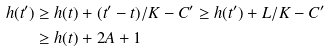<formula> <loc_0><loc_0><loc_500><loc_500>h ( t ^ { \prime } ) & \geq h ( t ) + ( t ^ { \prime } - t ) / K - C ^ { \prime } \geq h ( t ^ { \prime } ) + L / K - C ^ { \prime } \\ & \geq h ( t ) + 2 A + 1</formula> 